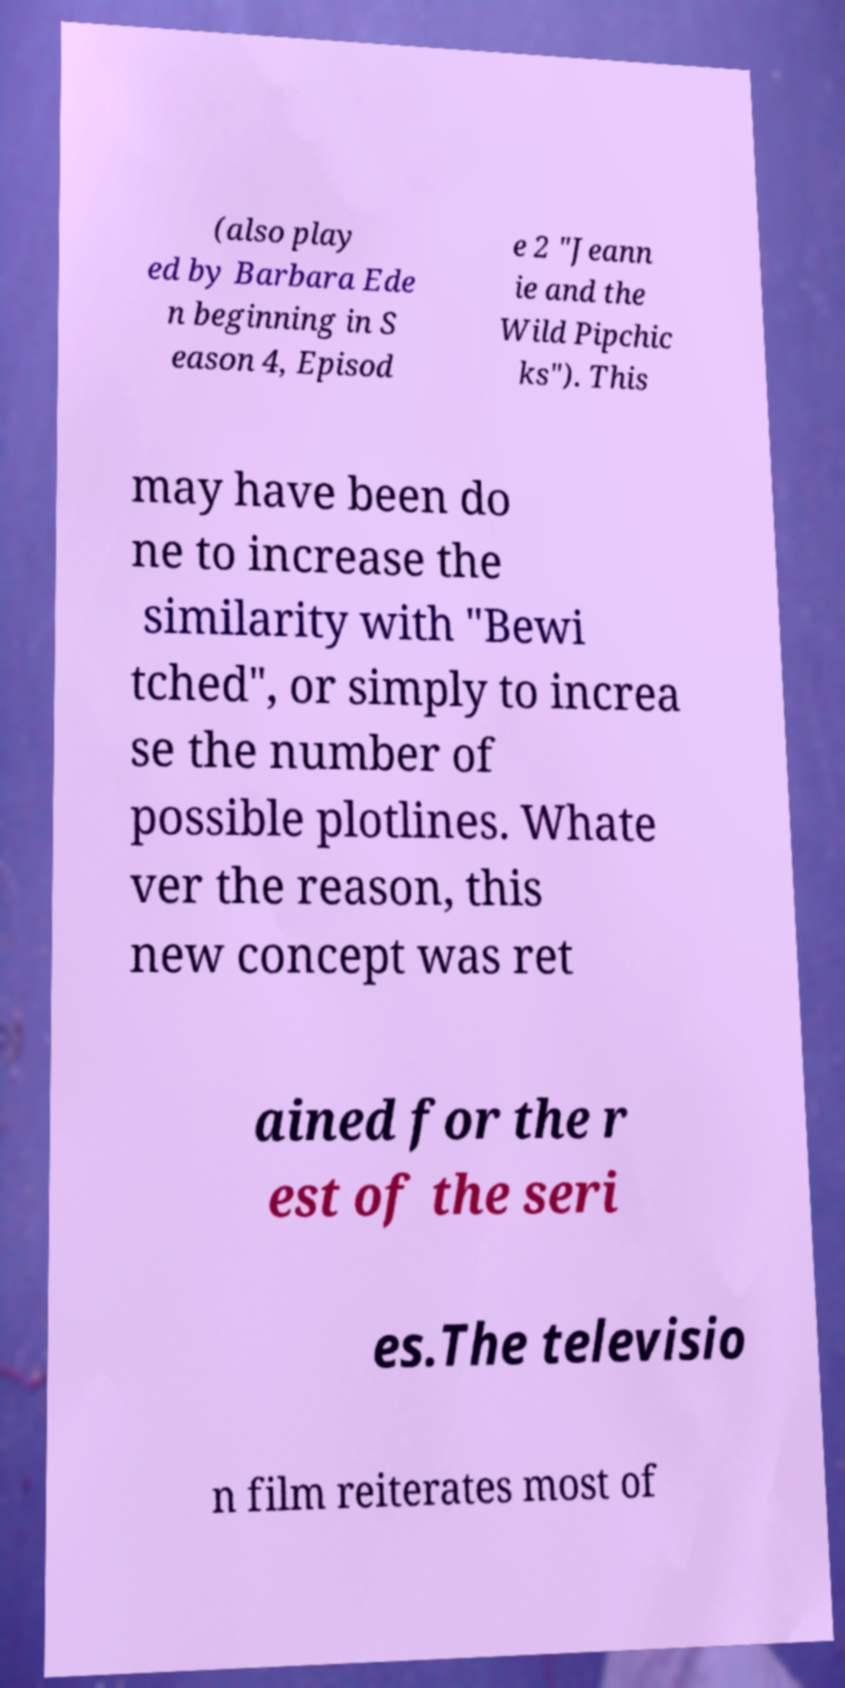I need the written content from this picture converted into text. Can you do that? (also play ed by Barbara Ede n beginning in S eason 4, Episod e 2 "Jeann ie and the Wild Pipchic ks"). This may have been do ne to increase the similarity with "Bewi tched", or simply to increa se the number of possible plotlines. Whate ver the reason, this new concept was ret ained for the r est of the seri es.The televisio n film reiterates most of 